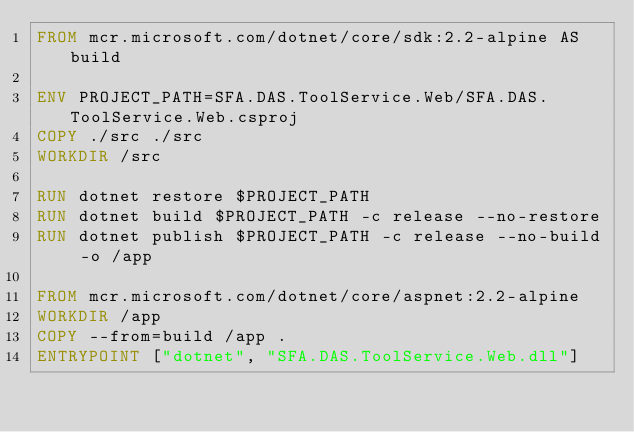<code> <loc_0><loc_0><loc_500><loc_500><_Dockerfile_>FROM mcr.microsoft.com/dotnet/core/sdk:2.2-alpine AS build

ENV PROJECT_PATH=SFA.DAS.ToolService.Web/SFA.DAS.ToolService.Web.csproj
COPY ./src ./src
WORKDIR /src

RUN dotnet restore $PROJECT_PATH
RUN dotnet build $PROJECT_PATH -c release --no-restore
RUN dotnet publish $PROJECT_PATH -c release --no-build -o /app

FROM mcr.microsoft.com/dotnet/core/aspnet:2.2-alpine
WORKDIR /app
COPY --from=build /app .
ENTRYPOINT ["dotnet", "SFA.DAS.ToolService.Web.dll"]
</code> 